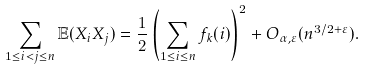Convert formula to latex. <formula><loc_0><loc_0><loc_500><loc_500>\sum _ { 1 \leq i < j \leq n } \mathbb { E } ( X _ { i } X _ { j } ) = \frac { 1 } { 2 } \left ( \sum _ { 1 \leq i \leq n } f _ { k } ( i ) \right ) ^ { 2 } + O _ { \alpha , \varepsilon } ( n ^ { 3 / 2 + \varepsilon } ) .</formula> 